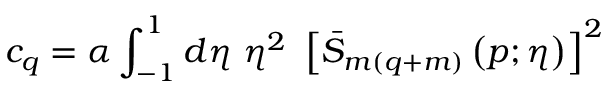<formula> <loc_0><loc_0><loc_500><loc_500>c _ { q } = \alpha \int _ { - 1 } ^ { 1 } d \eta \ \eta ^ { 2 } \ \left [ \bar { S } _ { m ( q + m ) } \left ( p ; \eta \right ) \right ] ^ { 2 }</formula> 